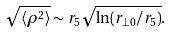<formula> <loc_0><loc_0><loc_500><loc_500>\sqrt { \langle \rho ^ { 2 } \rangle } \sim r _ { 5 } \sqrt { \ln ( r _ { \perp 0 } / r _ { 5 } ) } .</formula> 